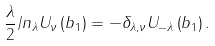<formula> <loc_0><loc_0><loc_500><loc_500>\frac { \lambda } { 2 } \slash { n } _ { \lambda } U _ { \nu } \left ( b _ { 1 } \right ) = - \delta _ { \lambda , \nu } U _ { - \lambda } \left ( b _ { 1 } \right ) .</formula> 